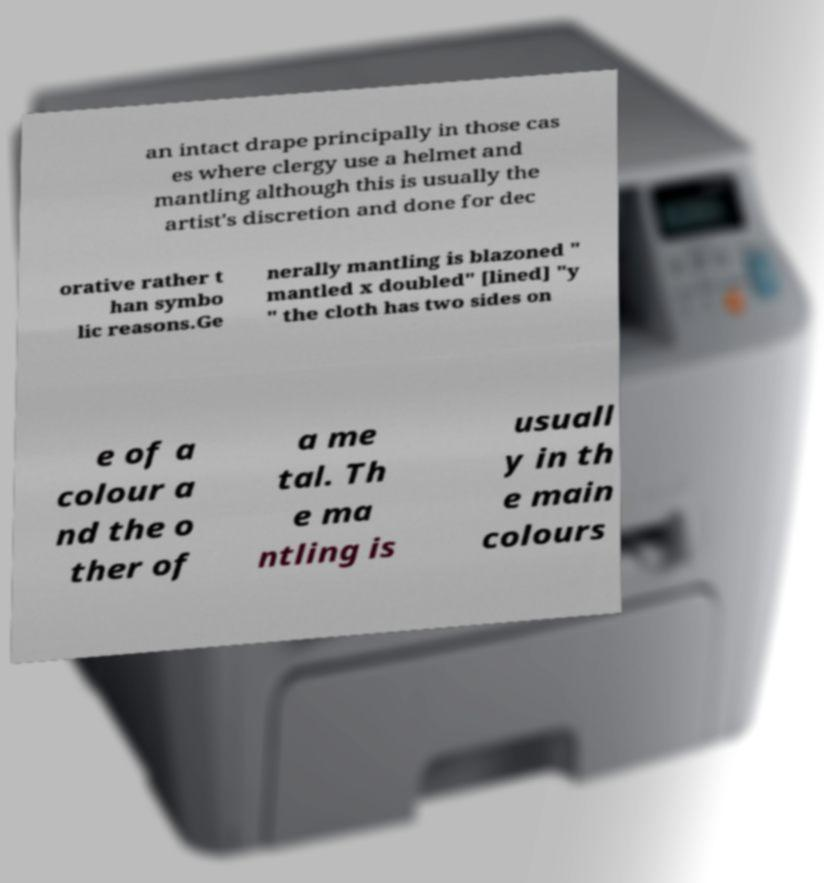Could you assist in decoding the text presented in this image and type it out clearly? an intact drape principally in those cas es where clergy use a helmet and mantling although this is usually the artist's discretion and done for dec orative rather t han symbo lic reasons.Ge nerally mantling is blazoned " mantled x doubled" [lined] "y " the cloth has two sides on e of a colour a nd the o ther of a me tal. Th e ma ntling is usuall y in th e main colours 